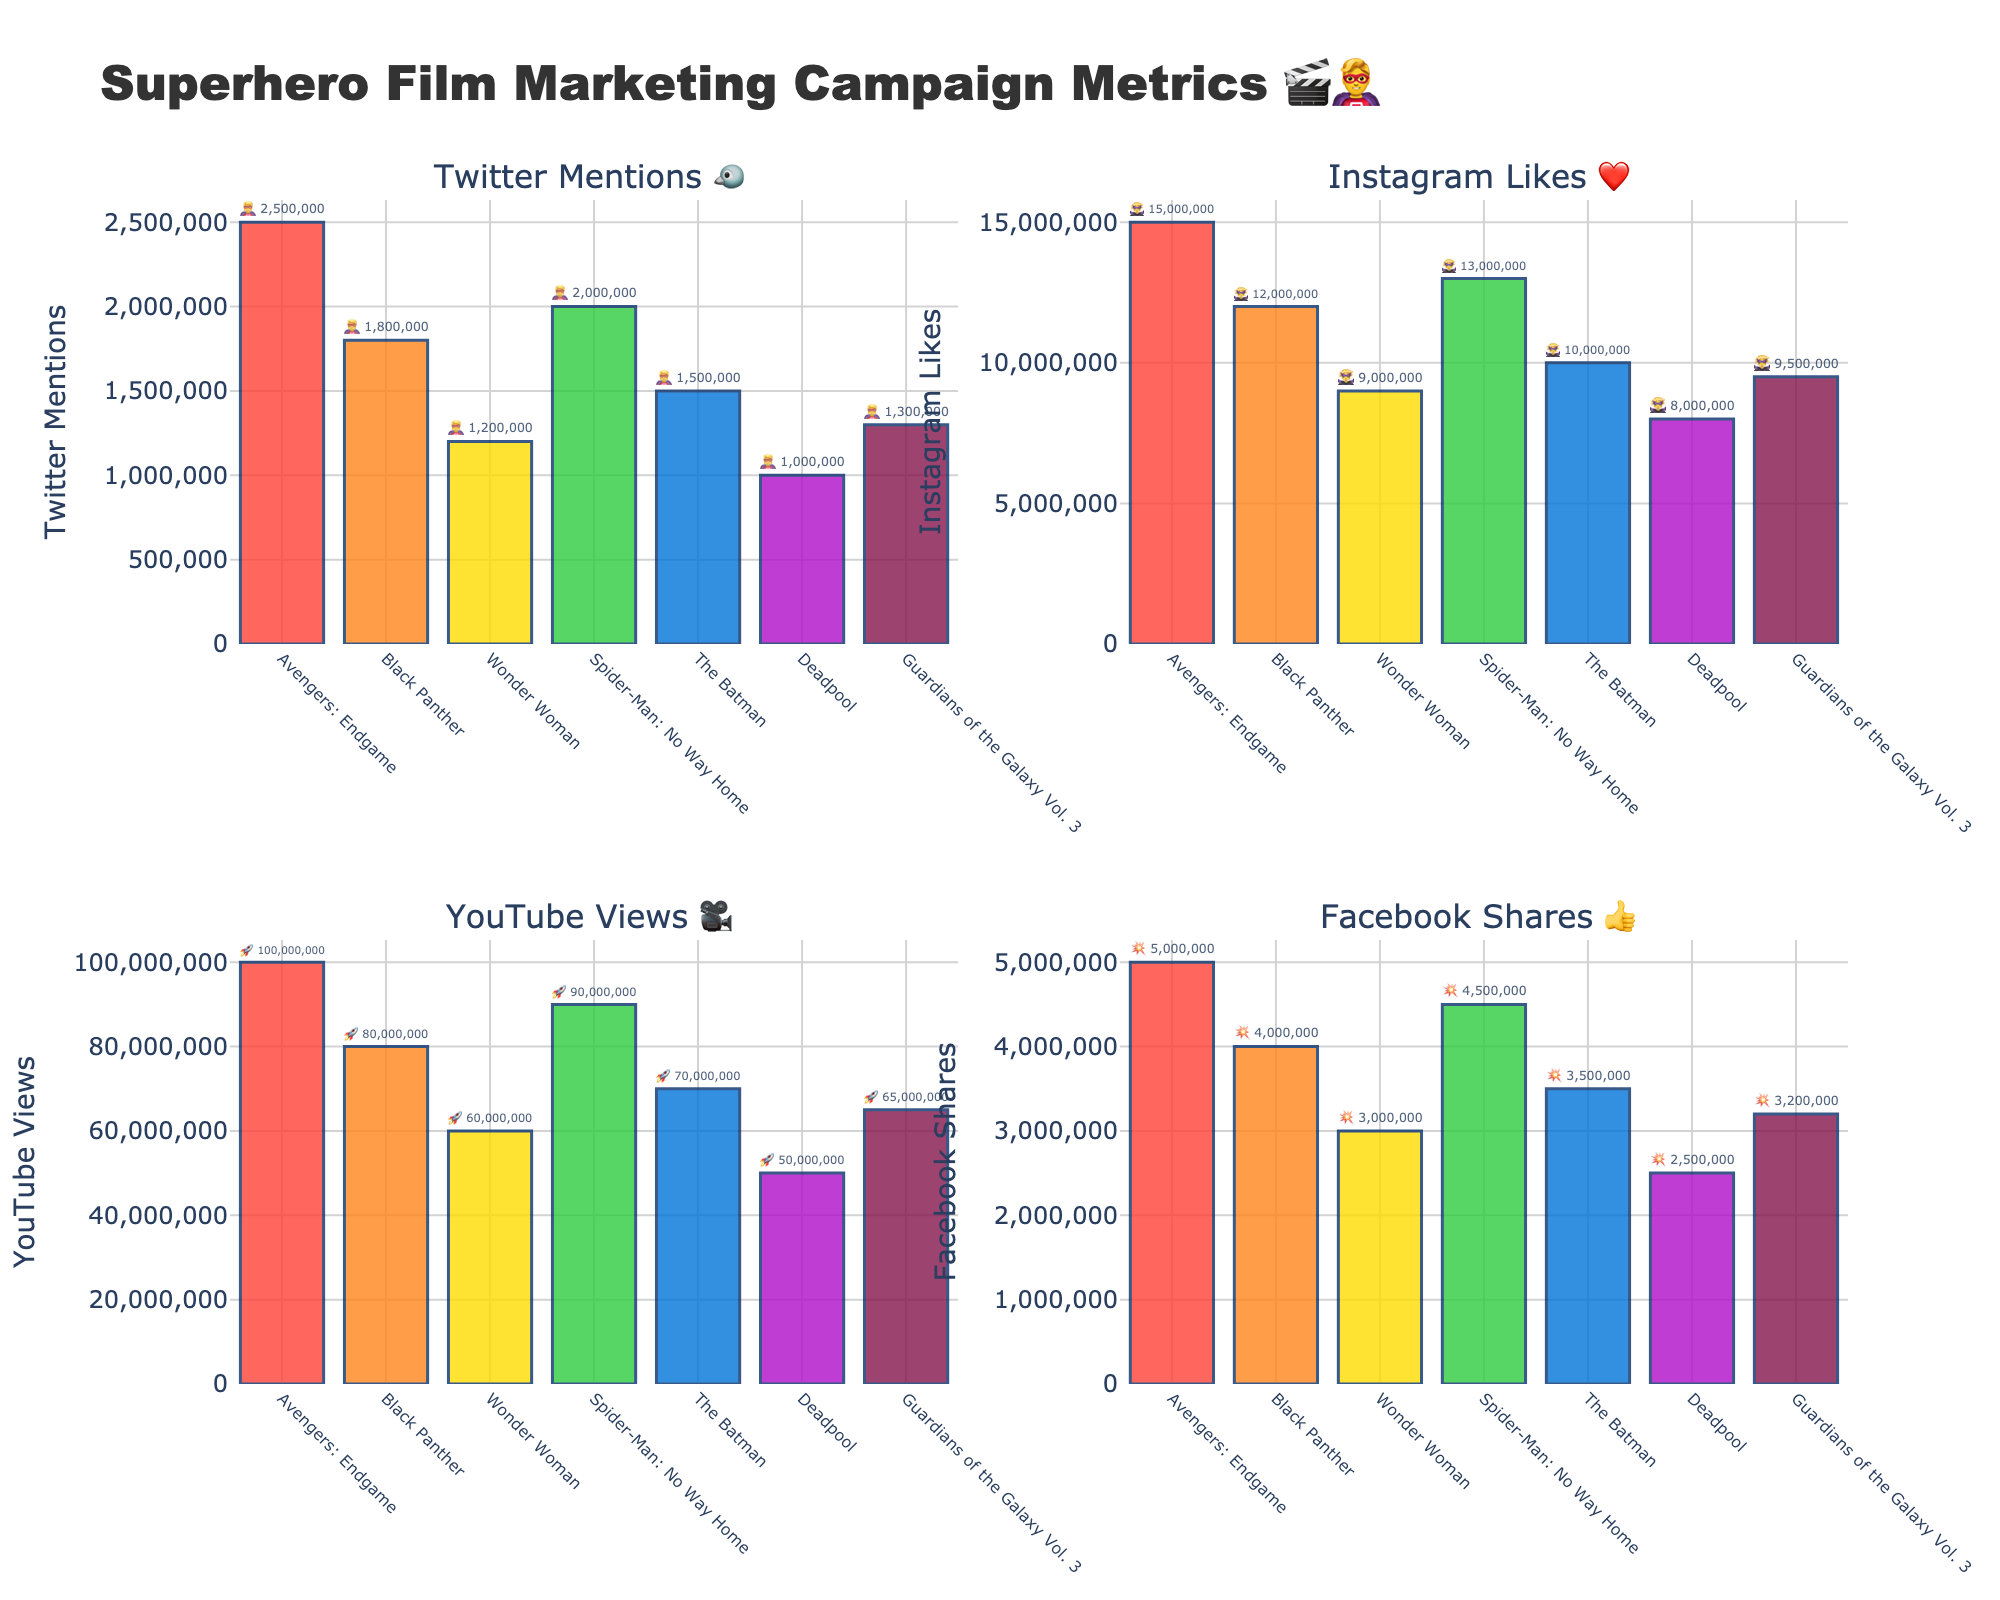Which film has the highest YouTube Views? Look at the "YouTube Views 🎥" subplot and identify the bar with the highest value. Avengers: Endgame stands out with 100,000,000 views.
Answer: Avengers: Endgame What is the total number of Instagram Likes for all films combined? Sum the Instagram Likes values for all films: 15,000,000 (Avengers: Endgame) + 12,000,000 (Black Panther) + 9,000,000 (Wonder Woman) + 13,000,000 (Spider-Man: No Way Home) + 10,000,000 (The Batman) + 8,000,000 (Deadpool) + 9,500,000 (Guardians of the Galaxy Vol. 3). The total is 76,500,000 Likes.
Answer: 76,500,000 Which film has the least Facebook Shares? Observe the "Facebook Shares 👍" subplot and find the bar with the smallest value, which is Deadpool with 2,500,000 shares.
Answer: Deadpool How many films have Twitter Mentions greater than 1,500,000? Check the "Twitter Mentions 🐦" subplot and count the bars with values greater than 1,500,000. These films are Avengers: Endgame, Black Panther, and Spider-Man: No Way Home (3 films).
Answer: 3 What is the average number of YouTube Views for Spider-Man: No Way Home and The Batman? Add the YouTube Views for both films: 90,000,000 (Spider-Man: No Way Home) + 70,000,000 (The Batman). Their sum is 160,000,000, and the average is 160,000,000 / 2 = 80,000,000.
Answer: 80,000,000 How many more Twitter Mentions does Avengers: Endgame have compared to Wonder Woman? Subtract Wonder Woman's Twitter Mentions (1,200,000) from Avengers: Endgame's Twitter Mentions (2,500,000), resulting in 1,300,000 more mentions.
Answer: 1,300,000 Which film has the second highest number of Instagram Likes? Refer to the "Instagram Likes ❤️" subplot and identify the second highest bar, which corresponds to Spider-Man: No Way Home with 13,000,000 Likes.
Answer: Spider-Man: No Way Home Which film has the second lowest amount of Facebook Shares? In the "Facebook Shares 👍" subplot, Deadpool has the lowest shares. The second smallest bar is for Guardians of the Galaxy Vol. 3 with 3,200,000 shares.
Answer: Guardians of the Galaxy Vol. 3 What is the combined total of Facebook Shares and Twitter Mentions for The Batman? Add The Batman's Facebook Shares (3,500,000) to its Twitter Mentions (1,500,000). The combined total is 5,000,000.
Answer: 5,000,000 Which film has a higher number of YouTube Views, Black Panther or Guardians of the Galaxy Vol. 3? Compare the YouTube Views subplot values for Black Panther (80,000,000) and Guardians of the Galaxy Vol. 3 (65,000,000). Black Panther has more views.
Answer: Black Panther 